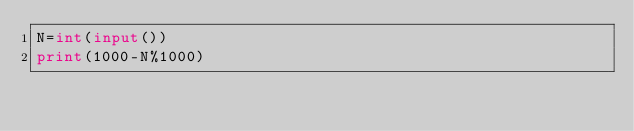<code> <loc_0><loc_0><loc_500><loc_500><_Python_>N=int(input())
print(1000-N%1000)</code> 